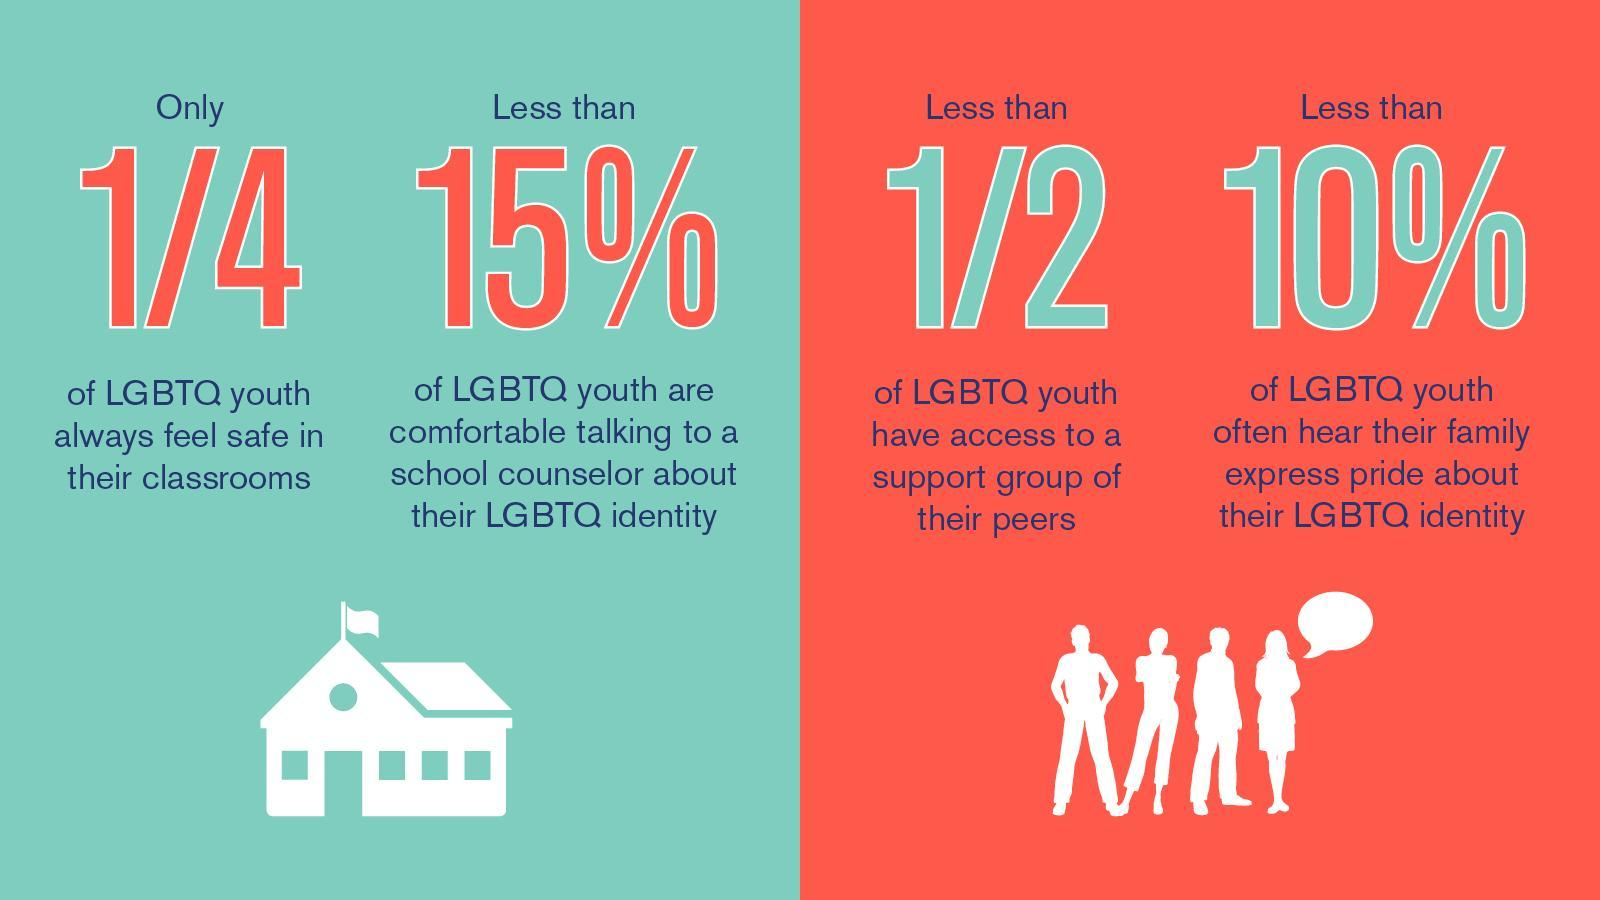what % of LGBTQ youth are comfortable talking to a school counseller
Answer the question with a short phrase. less than 15% how much of LGBTQ youth do not feel safe in their classrooms 3/4 what % of LGBTQ youth often hear their family express pride about their identity less than 10% 